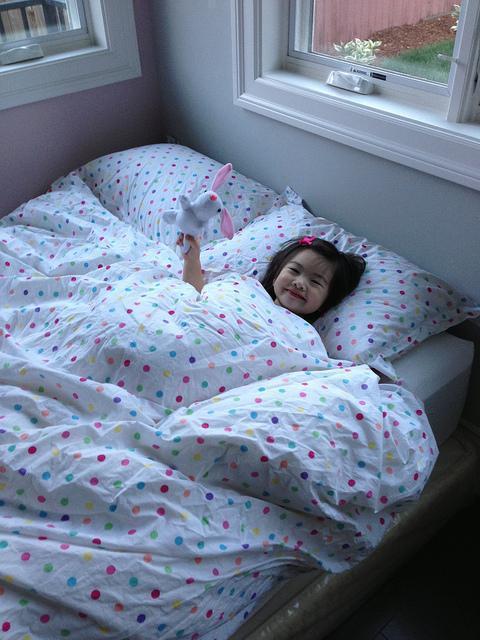Who is in the bed?
Answer the question by selecting the correct answer among the 4 following choices.
Options: Mom, rabbit, little girl, man. Little girl. 